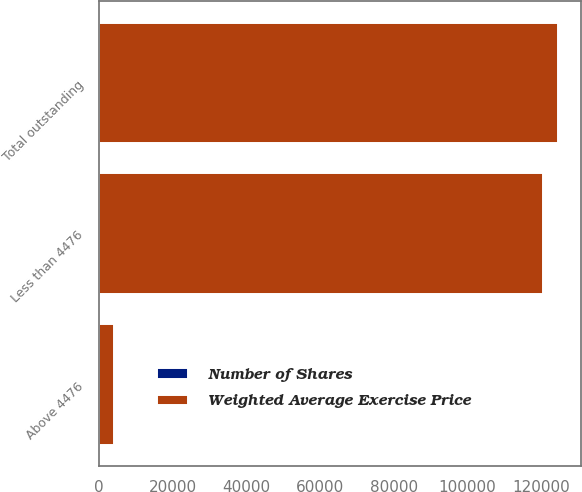<chart> <loc_0><loc_0><loc_500><loc_500><stacked_bar_chart><ecel><fcel>Less than 4476<fcel>Above 4476<fcel>Total outstanding<nl><fcel>Weighted Average Exercise Price<fcel>120418<fcel>4073<fcel>124491<nl><fcel>Number of Shares<fcel>19.84<fcel>58.66<fcel>21.11<nl></chart> 